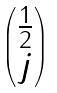Convert formula to latex. <formula><loc_0><loc_0><loc_500><loc_500>\begin{pmatrix} \frac { 1 } { 2 } \\ j \end{pmatrix}</formula> 